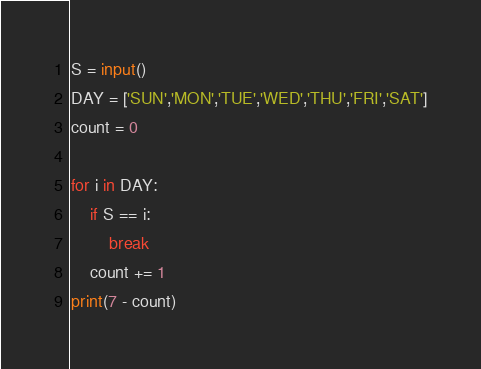Convert code to text. <code><loc_0><loc_0><loc_500><loc_500><_Python_>S = input()
DAY = ['SUN','MON','TUE','WED','THU','FRI','SAT']
count = 0

for i in DAY:
    if S == i:
        break
    count += 1
print(7 - count)</code> 